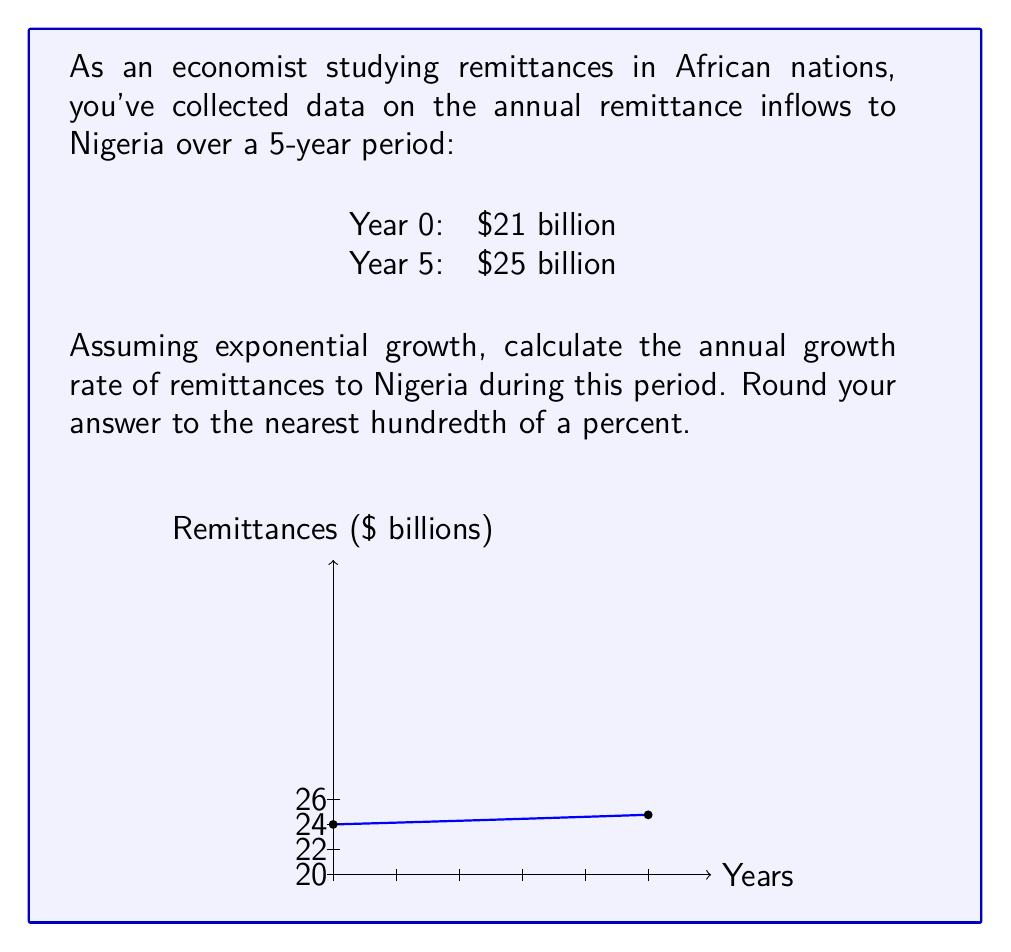Solve this math problem. To solve this problem, we'll use the exponential growth formula:

$$A = P(1 + r)^t$$

Where:
A = Final amount
P = Initial amount
r = Annual growth rate (as a decimal)
t = Time period in years

We know:
P = $21 billion (Year 0)
A = $25 billion (Year 5)
t = 5 years

Let's plug these values into the formula:

$$25 = 21(1 + r)^5$$

Now, we need to solve for r:

1) Divide both sides by 21:
   $$\frac{25}{21} = (1 + r)^5$$

2) Take the 5th root of both sides:
   $$\sqrt[5]{\frac{25}{21}} = 1 + r$$

3) Subtract 1 from both sides:
   $$\sqrt[5]{\frac{25}{21}} - 1 = r$$

4) Calculate the value:
   $$r \approx 0.0352$$

5) Convert to a percentage:
   $$0.0352 \times 100 = 3.52\%$$

Rounding to the nearest hundredth of a percent gives us 3.52%.
Answer: 3.52% 